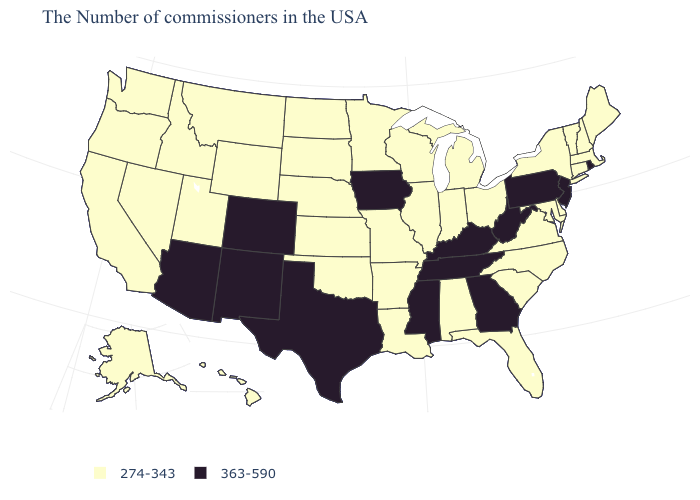Which states hav the highest value in the West?
Keep it brief. Colorado, New Mexico, Arizona. What is the value of Wisconsin?
Give a very brief answer. 274-343. Which states have the highest value in the USA?
Give a very brief answer. Rhode Island, New Jersey, Pennsylvania, West Virginia, Georgia, Kentucky, Tennessee, Mississippi, Iowa, Texas, Colorado, New Mexico, Arizona. Name the states that have a value in the range 274-343?
Write a very short answer. Maine, Massachusetts, New Hampshire, Vermont, Connecticut, New York, Delaware, Maryland, Virginia, North Carolina, South Carolina, Ohio, Florida, Michigan, Indiana, Alabama, Wisconsin, Illinois, Louisiana, Missouri, Arkansas, Minnesota, Kansas, Nebraska, Oklahoma, South Dakota, North Dakota, Wyoming, Utah, Montana, Idaho, Nevada, California, Washington, Oregon, Alaska, Hawaii. Does Nevada have the lowest value in the West?
Be succinct. Yes. Name the states that have a value in the range 363-590?
Answer briefly. Rhode Island, New Jersey, Pennsylvania, West Virginia, Georgia, Kentucky, Tennessee, Mississippi, Iowa, Texas, Colorado, New Mexico, Arizona. Name the states that have a value in the range 363-590?
Write a very short answer. Rhode Island, New Jersey, Pennsylvania, West Virginia, Georgia, Kentucky, Tennessee, Mississippi, Iowa, Texas, Colorado, New Mexico, Arizona. What is the highest value in states that border Oklahoma?
Give a very brief answer. 363-590. What is the value of Alaska?
Concise answer only. 274-343. Does South Dakota have the same value as Washington?
Write a very short answer. Yes. Name the states that have a value in the range 363-590?
Keep it brief. Rhode Island, New Jersey, Pennsylvania, West Virginia, Georgia, Kentucky, Tennessee, Mississippi, Iowa, Texas, Colorado, New Mexico, Arizona. Does New Mexico have the highest value in the West?
Keep it brief. Yes. What is the value of Texas?
Short answer required. 363-590. Name the states that have a value in the range 274-343?
Keep it brief. Maine, Massachusetts, New Hampshire, Vermont, Connecticut, New York, Delaware, Maryland, Virginia, North Carolina, South Carolina, Ohio, Florida, Michigan, Indiana, Alabama, Wisconsin, Illinois, Louisiana, Missouri, Arkansas, Minnesota, Kansas, Nebraska, Oklahoma, South Dakota, North Dakota, Wyoming, Utah, Montana, Idaho, Nevada, California, Washington, Oregon, Alaska, Hawaii. What is the highest value in the Northeast ?
Keep it brief. 363-590. 